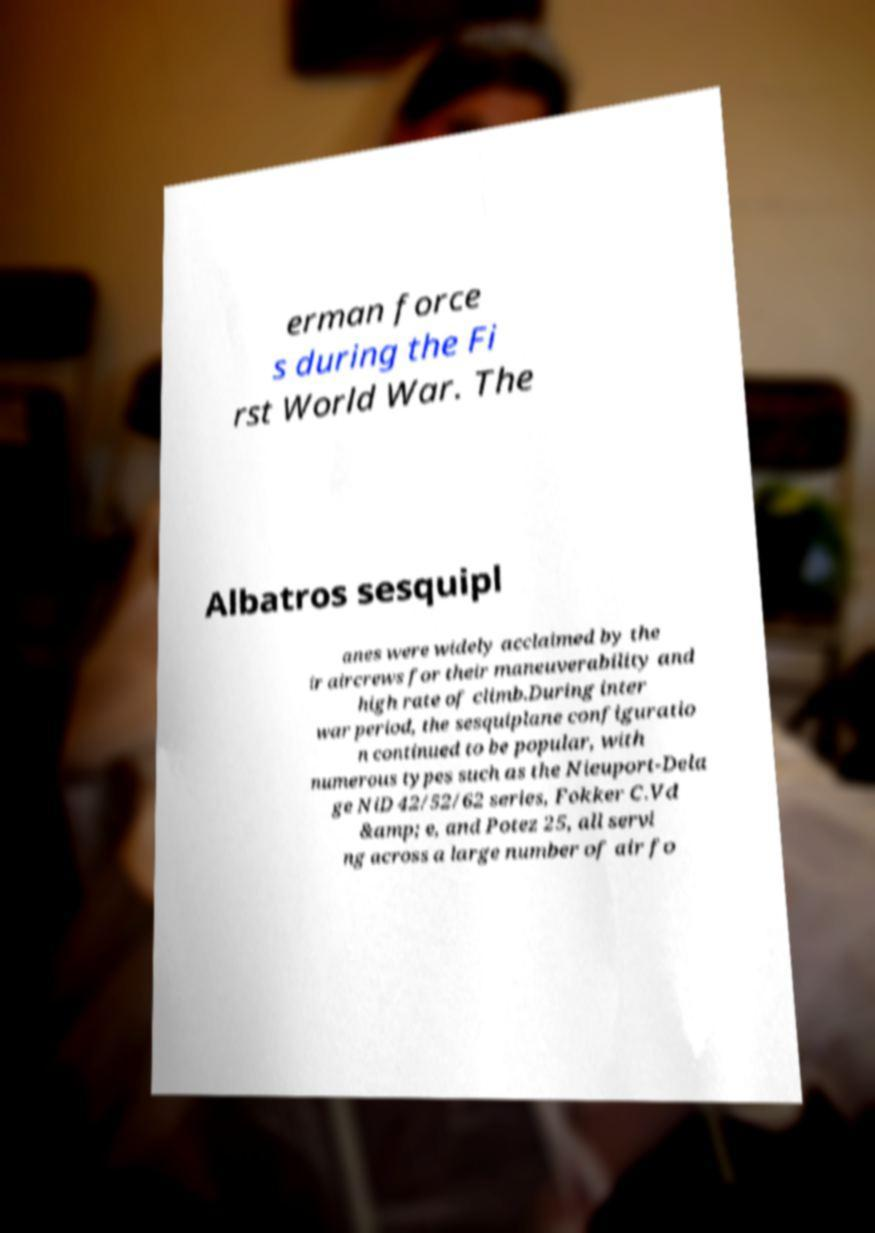Could you extract and type out the text from this image? erman force s during the Fi rst World War. The Albatros sesquipl anes were widely acclaimed by the ir aircrews for their maneuverability and high rate of climb.During inter war period, the sesquiplane configuratio n continued to be popular, with numerous types such as the Nieuport-Dela ge NiD 42/52/62 series, Fokker C.Vd &amp; e, and Potez 25, all servi ng across a large number of air fo 